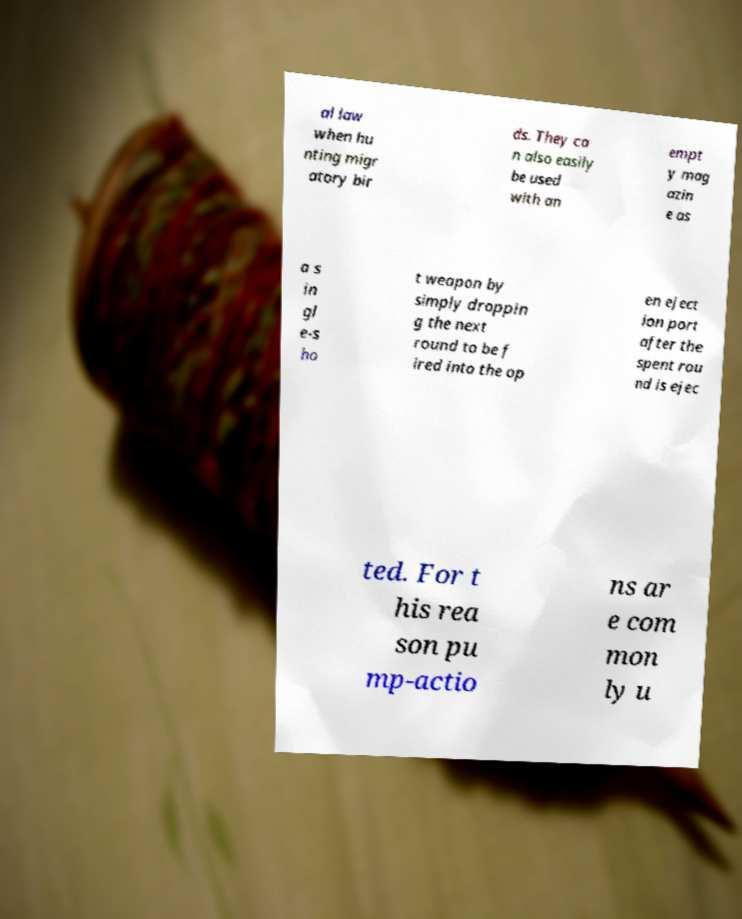Can you read and provide the text displayed in the image?This photo seems to have some interesting text. Can you extract and type it out for me? al law when hu nting migr atory bir ds. They ca n also easily be used with an empt y mag azin e as a s in gl e-s ho t weapon by simply droppin g the next round to be f ired into the op en eject ion port after the spent rou nd is ejec ted. For t his rea son pu mp-actio ns ar e com mon ly u 